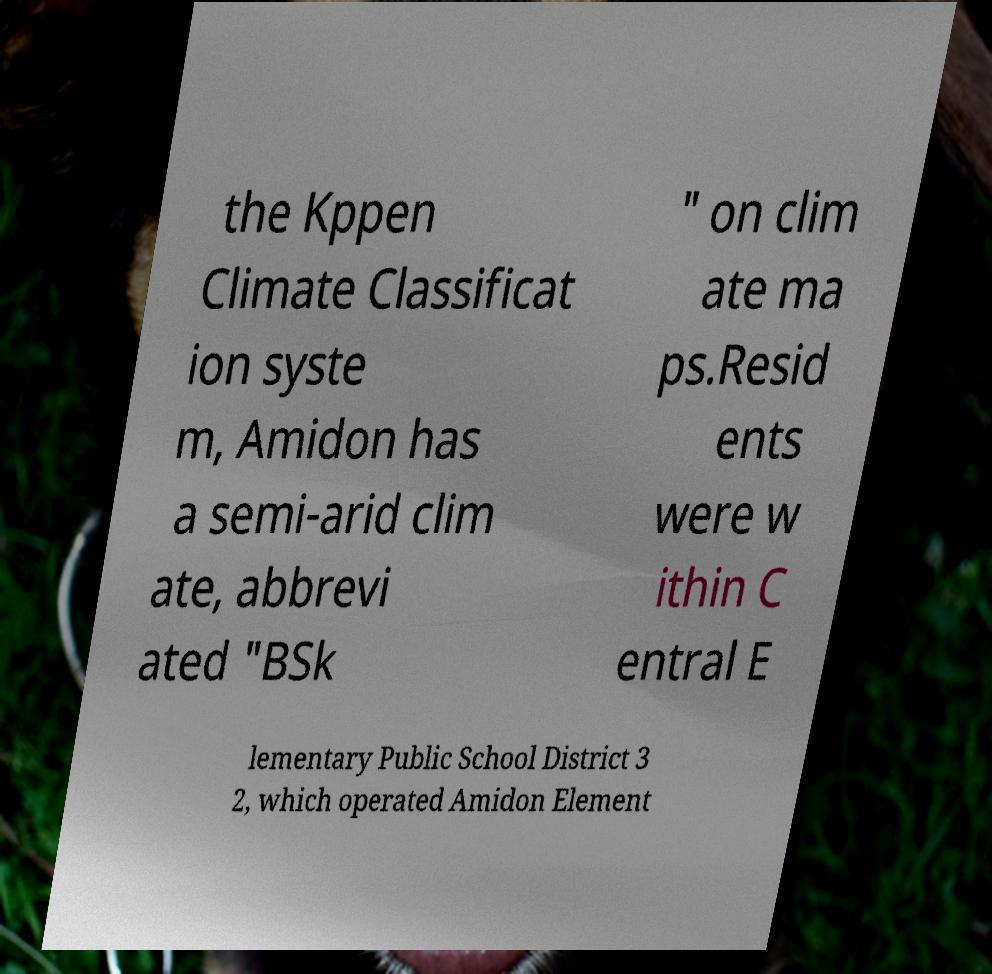There's text embedded in this image that I need extracted. Can you transcribe it verbatim? the Kppen Climate Classificat ion syste m, Amidon has a semi-arid clim ate, abbrevi ated "BSk " on clim ate ma ps.Resid ents were w ithin C entral E lementary Public School District 3 2, which operated Amidon Element 